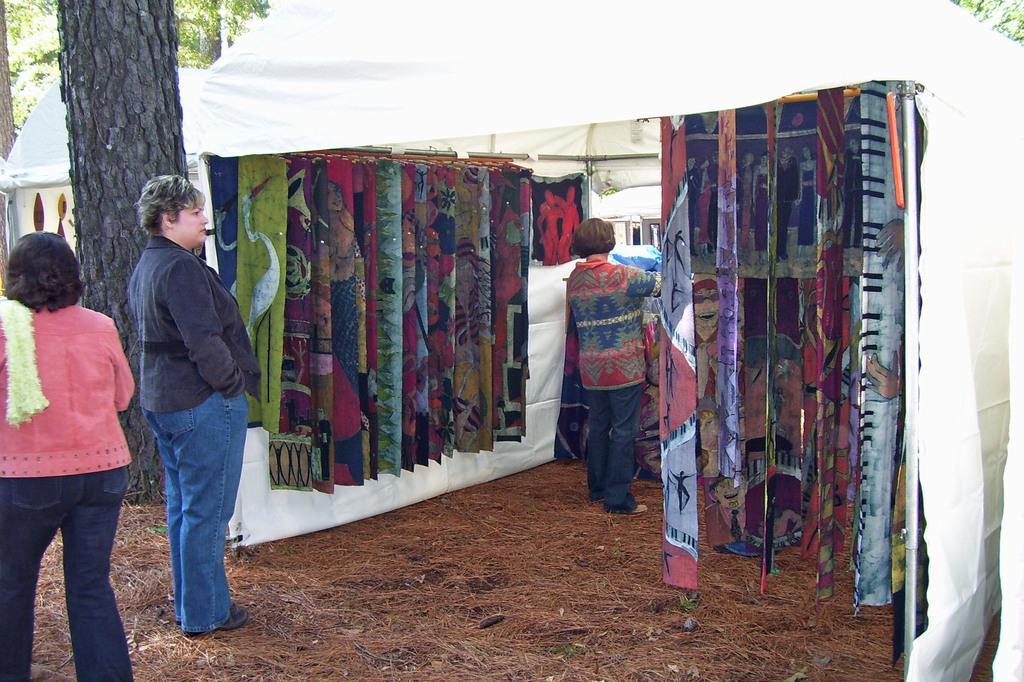Please provide a concise description of this image. This picture describe about the open cloth shop. In front we can see a woman wearing black jacket standing and watching the cloth. Behind there is a tree trunk. 